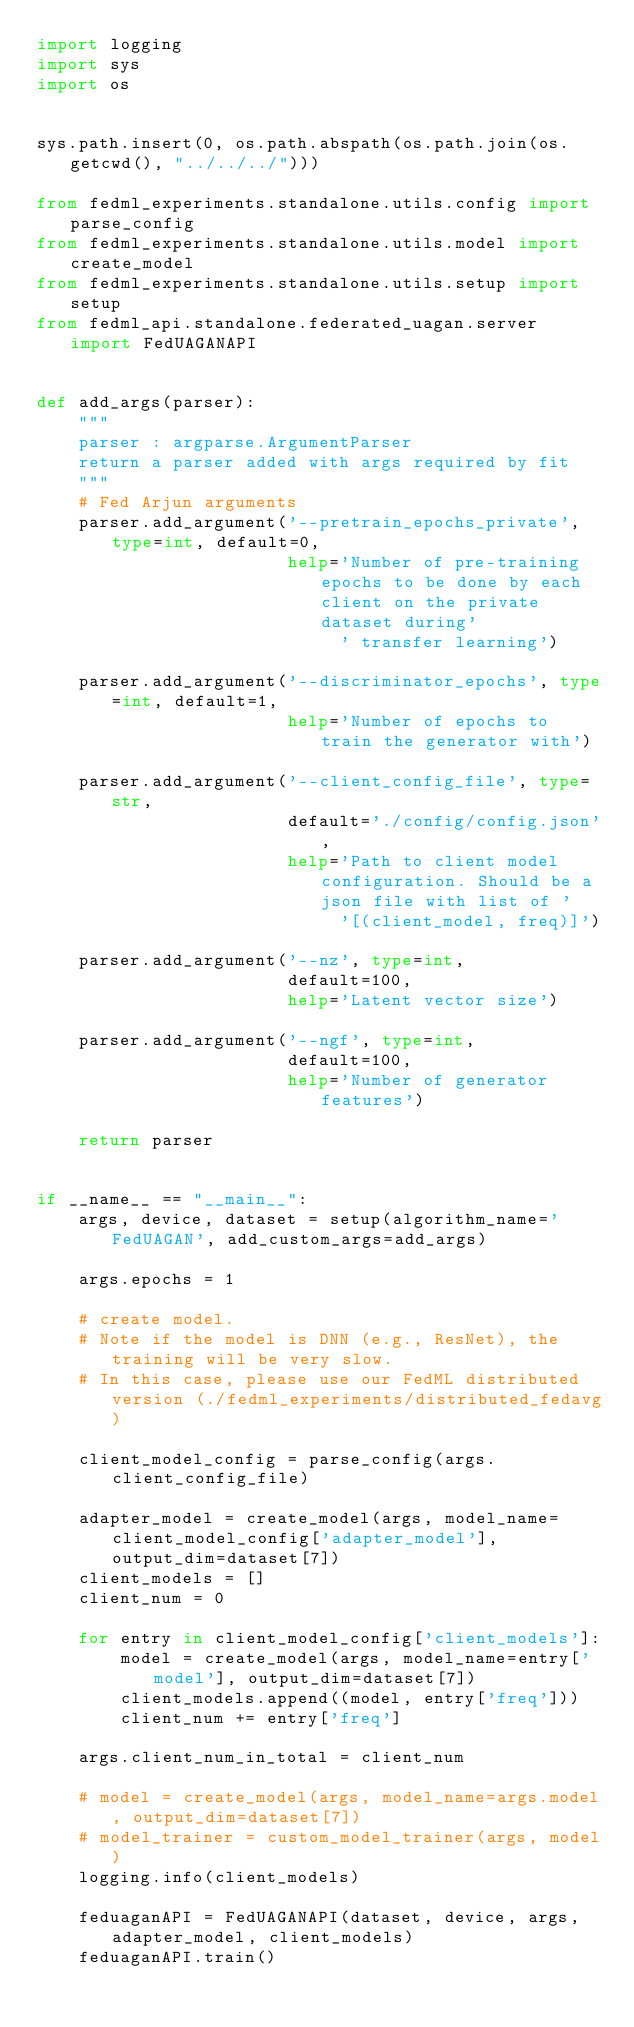<code> <loc_0><loc_0><loc_500><loc_500><_Python_>import logging
import sys
import os


sys.path.insert(0, os.path.abspath(os.path.join(os.getcwd(), "../../../")))

from fedml_experiments.standalone.utils.config import parse_config
from fedml_experiments.standalone.utils.model import create_model
from fedml_experiments.standalone.utils.setup import setup
from fedml_api.standalone.federated_uagan.server import FedUAGANAPI


def add_args(parser):
    """
    parser : argparse.ArgumentParser
    return a parser added with args required by fit
    """
    # Fed Arjun arguments
    parser.add_argument('--pretrain_epochs_private', type=int, default=0,
                        help='Number of pre-training epochs to be done by each client on the private dataset during'
                             ' transfer learning')

    parser.add_argument('--discriminator_epochs', type=int, default=1,
                        help='Number of epochs to train the generator with')

    parser.add_argument('--client_config_file', type=str,
                        default='./config/config.json',
                        help='Path to client model configuration. Should be a json file with list of '
                             '[(client_model, freq)]')

    parser.add_argument('--nz', type=int,
                        default=100,
                        help='Latent vector size')

    parser.add_argument('--ngf', type=int,
                        default=100,
                        help='Number of generator features')

    return parser


if __name__ == "__main__":
    args, device, dataset = setup(algorithm_name='FedUAGAN', add_custom_args=add_args)

    args.epochs = 1

    # create model.
    # Note if the model is DNN (e.g., ResNet), the training will be very slow.
    # In this case, please use our FedML distributed version (./fedml_experiments/distributed_fedavg)

    client_model_config = parse_config(args.client_config_file)

    adapter_model = create_model(args, model_name=client_model_config['adapter_model'], output_dim=dataset[7])
    client_models = []
    client_num = 0

    for entry in client_model_config['client_models']:
        model = create_model(args, model_name=entry['model'], output_dim=dataset[7])
        client_models.append((model, entry['freq']))
        client_num += entry['freq']

    args.client_num_in_total = client_num

    # model = create_model(args, model_name=args.model, output_dim=dataset[7])
    # model_trainer = custom_model_trainer(args, model)
    logging.info(client_models)

    feduaganAPI = FedUAGANAPI(dataset, device, args, adapter_model, client_models)
    feduaganAPI.train()
</code> 